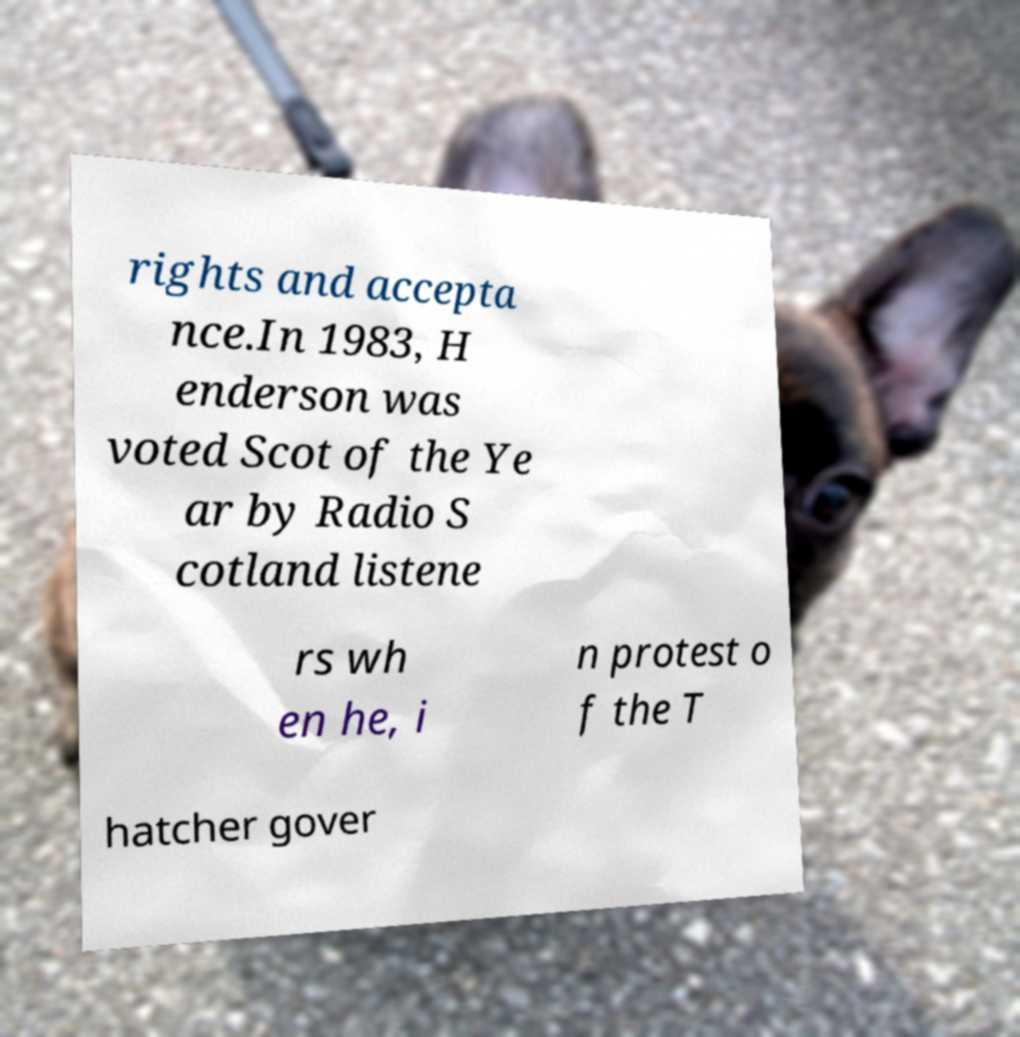Please read and relay the text visible in this image. What does it say? rights and accepta nce.In 1983, H enderson was voted Scot of the Ye ar by Radio S cotland listene rs wh en he, i n protest o f the T hatcher gover 